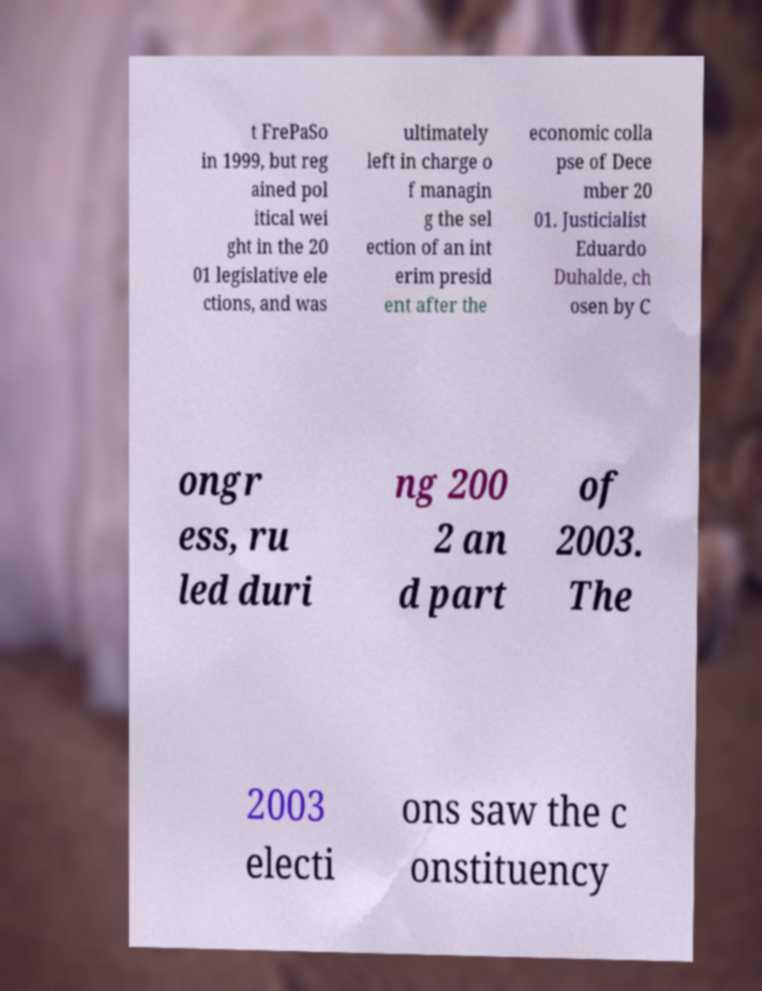Can you accurately transcribe the text from the provided image for me? t FrePaSo in 1999, but reg ained pol itical wei ght in the 20 01 legislative ele ctions, and was ultimately left in charge o f managin g the sel ection of an int erim presid ent after the economic colla pse of Dece mber 20 01. Justicialist Eduardo Duhalde, ch osen by C ongr ess, ru led duri ng 200 2 an d part of 2003. The 2003 electi ons saw the c onstituency 